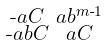Convert formula to latex. <formula><loc_0><loc_0><loc_500><loc_500>\begin{smallmatrix} \text {-} a C & a b ^ { m \text {-} 1 } \\ \text {-} a b C & a C \end{smallmatrix}</formula> 